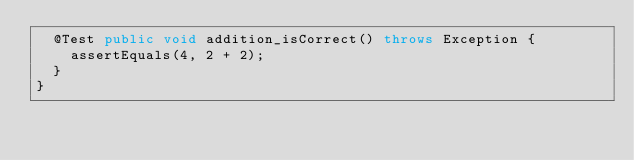Convert code to text. <code><loc_0><loc_0><loc_500><loc_500><_Java_>  @Test public void addition_isCorrect() throws Exception {
    assertEquals(4, 2 + 2);
  }
}
</code> 